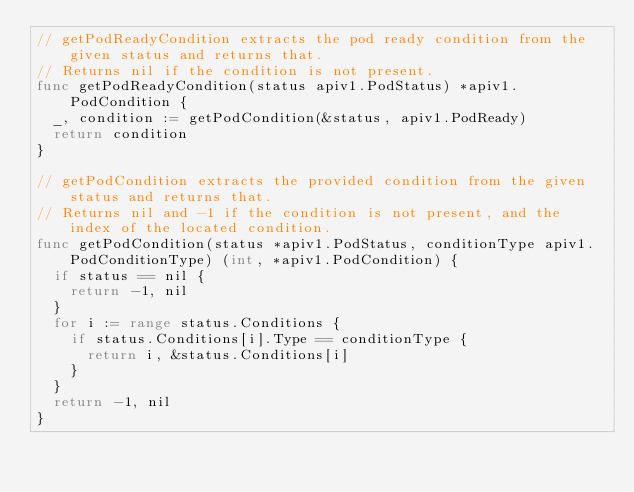Convert code to text. <code><loc_0><loc_0><loc_500><loc_500><_Go_>// getPodReadyCondition extracts the pod ready condition from the given status and returns that.
// Returns nil if the condition is not present.
func getPodReadyCondition(status apiv1.PodStatus) *apiv1.PodCondition {
	_, condition := getPodCondition(&status, apiv1.PodReady)
	return condition
}

// getPodCondition extracts the provided condition from the given status and returns that.
// Returns nil and -1 if the condition is not present, and the index of the located condition.
func getPodCondition(status *apiv1.PodStatus, conditionType apiv1.PodConditionType) (int, *apiv1.PodCondition) {
	if status == nil {
		return -1, nil
	}
	for i := range status.Conditions {
		if status.Conditions[i].Type == conditionType {
			return i, &status.Conditions[i]
		}
	}
	return -1, nil
}
</code> 